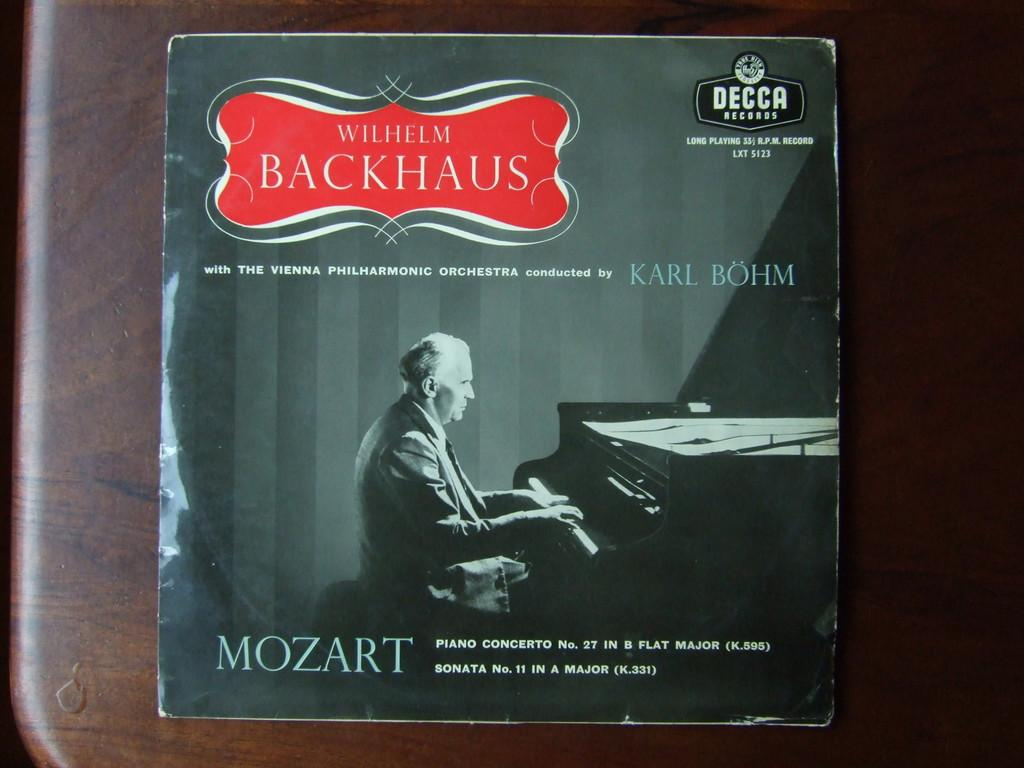<image>
Create a compact narrative representing the image presented. A Mozart record titled Wilhelm Backhaus has a man playing piano on it. 